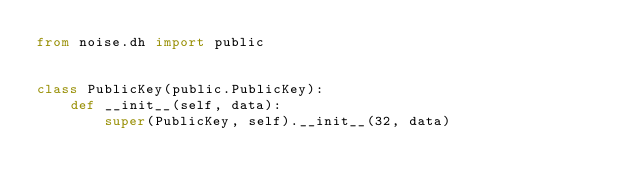Convert code to text. <code><loc_0><loc_0><loc_500><loc_500><_Python_>from noise.dh import public


class PublicKey(public.PublicKey):
    def __init__(self, data):
        super(PublicKey, self).__init__(32, data)
</code> 